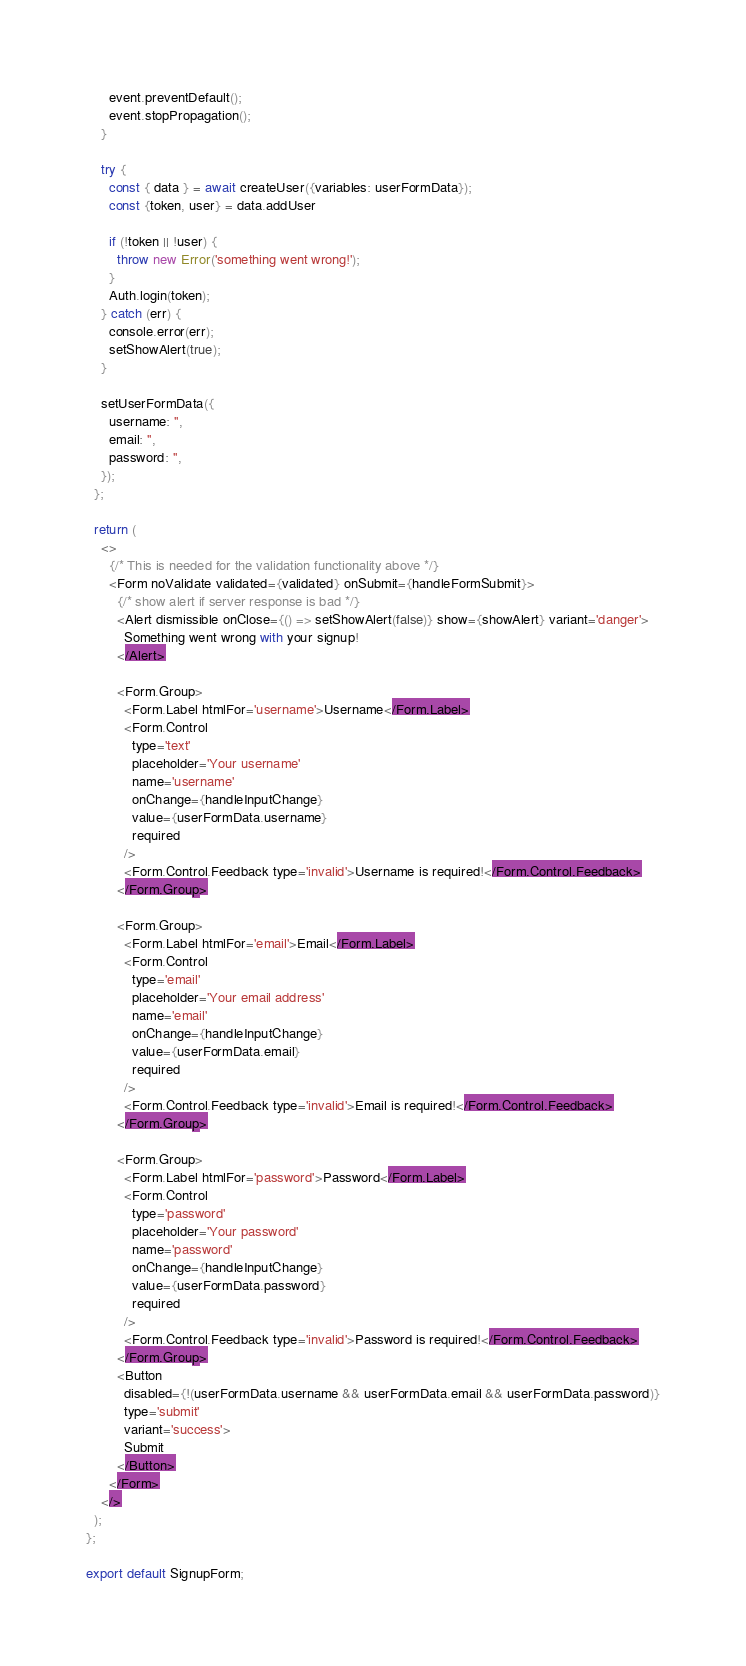Convert code to text. <code><loc_0><loc_0><loc_500><loc_500><_JavaScript_>      event.preventDefault();
      event.stopPropagation();
    }

    try {
      const { data } = await createUser({variables: userFormData});
      const {token, user} = data.addUser

      if (!token || !user) {
        throw new Error('something went wrong!');
      }
      Auth.login(token);
    } catch (err) {
      console.error(err);
      setShowAlert(true);
    }

    setUserFormData({
      username: '',
      email: '',
      password: '',
    });
  };

  return (
    <>
      {/* This is needed for the validation functionality above */}
      <Form noValidate validated={validated} onSubmit={handleFormSubmit}>
        {/* show alert if server response is bad */}
        <Alert dismissible onClose={() => setShowAlert(false)} show={showAlert} variant='danger'>
          Something went wrong with your signup!
        </Alert>

        <Form.Group>
          <Form.Label htmlFor='username'>Username</Form.Label>
          <Form.Control
            type='text'
            placeholder='Your username'
            name='username'
            onChange={handleInputChange}
            value={userFormData.username}
            required
          />
          <Form.Control.Feedback type='invalid'>Username is required!</Form.Control.Feedback>
        </Form.Group>

        <Form.Group>
          <Form.Label htmlFor='email'>Email</Form.Label>
          <Form.Control
            type='email'
            placeholder='Your email address'
            name='email'
            onChange={handleInputChange}
            value={userFormData.email}
            required
          />
          <Form.Control.Feedback type='invalid'>Email is required!</Form.Control.Feedback>
        </Form.Group>

        <Form.Group>
          <Form.Label htmlFor='password'>Password</Form.Label>
          <Form.Control
            type='password'
            placeholder='Your password'
            name='password'
            onChange={handleInputChange}
            value={userFormData.password}
            required
          />
          <Form.Control.Feedback type='invalid'>Password is required!</Form.Control.Feedback>
        </Form.Group>
        <Button
          disabled={!(userFormData.username && userFormData.email && userFormData.password)}
          type='submit'
          variant='success'>
          Submit
        </Button>
      </Form>
    </>
  );
};

export default SignupForm;
</code> 